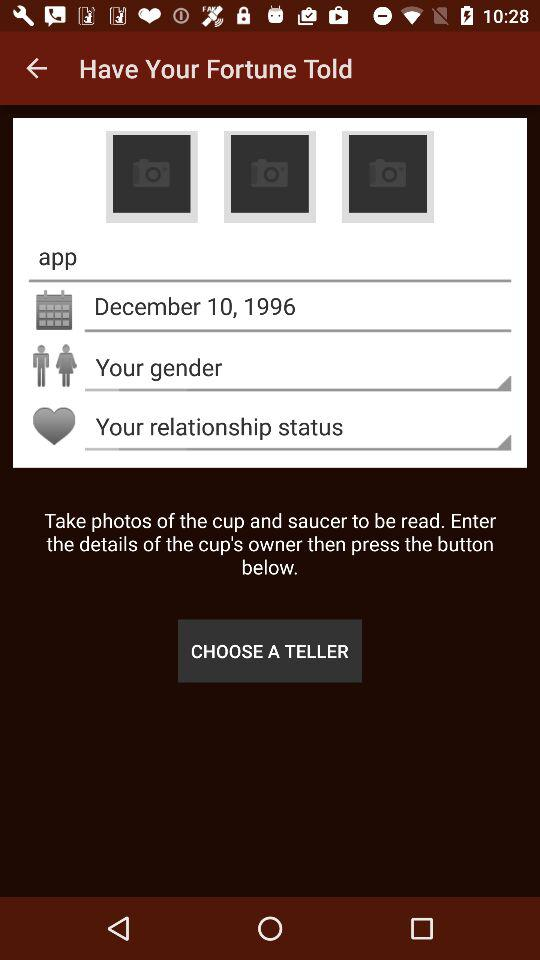What's the entered date? The date entered is December 10, 1996. 